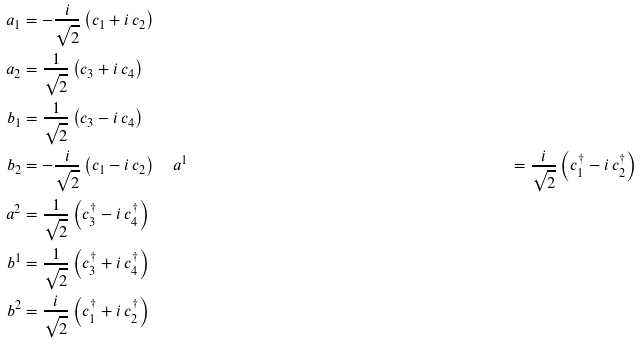Convert formula to latex. <formula><loc_0><loc_0><loc_500><loc_500>a _ { 1 } & = - \frac { i } { \sqrt { 2 } } \left ( c _ { 1 } + i \, c _ { 2 } \right ) \\ a _ { 2 } & = \frac { 1 } { \sqrt { 2 } } \left ( c _ { 3 } + i \, c _ { 4 } \right ) \\ b _ { 1 } & = \frac { 1 } { \sqrt { 2 } } \left ( c _ { 3 } - i \, c _ { 4 } \right ) \\ b _ { 2 } & = - \frac { i } { \sqrt { 2 } } \left ( c _ { 1 } - i \, c _ { 2 } \right ) \quad a ^ { 1 } & = \frac { i } { \sqrt { 2 } } \left ( c _ { 1 } ^ { \dag } - i \, c _ { 2 } ^ { \dag } \right ) \\ a ^ { 2 } & = \frac { 1 } { \sqrt { 2 } } \left ( c _ { 3 } ^ { \dag } - i \, c _ { 4 } ^ { \dag } \right ) \\ b ^ { 1 } & = \frac { 1 } { \sqrt { 2 } } \left ( c _ { 3 } ^ { \dag } + i \, c _ { 4 } ^ { \dag } \right ) \\ b ^ { 2 } & = \frac { i } { \sqrt { 2 } } \left ( c _ { 1 } ^ { \dag } + i \, c _ { 2 } ^ { \dag } \right )</formula> 